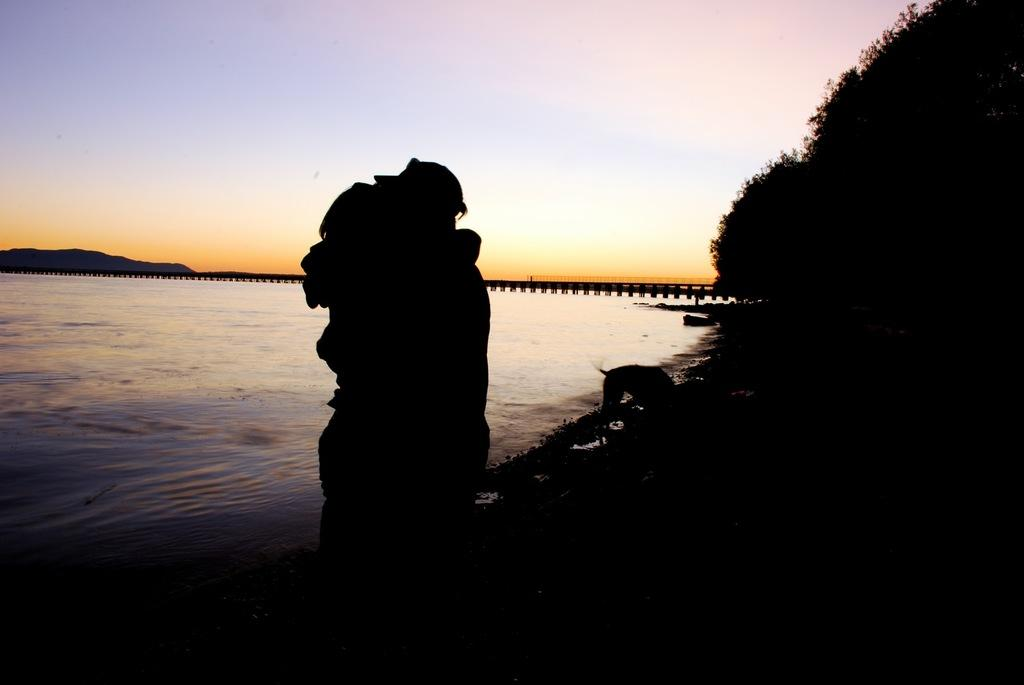What are the two people in the image doing? The two people in the image are hugging. What type of animal is present in the image? There is a dog in the image. What can be seen on the right side of the image? There are trees on the right side of the image. What natural feature is visible in the image? There is water visible in the image. What is located in the background of the image? There are mountains in the background of the image. What man-made structure can be seen in the image? There is a bridge in the image. What part of the natural environment is visible in the image? The sky is visible in the image. What type of collar is the cheese wearing in the image? There is no cheese present in the image, and therefore no collar can be associated with it. 